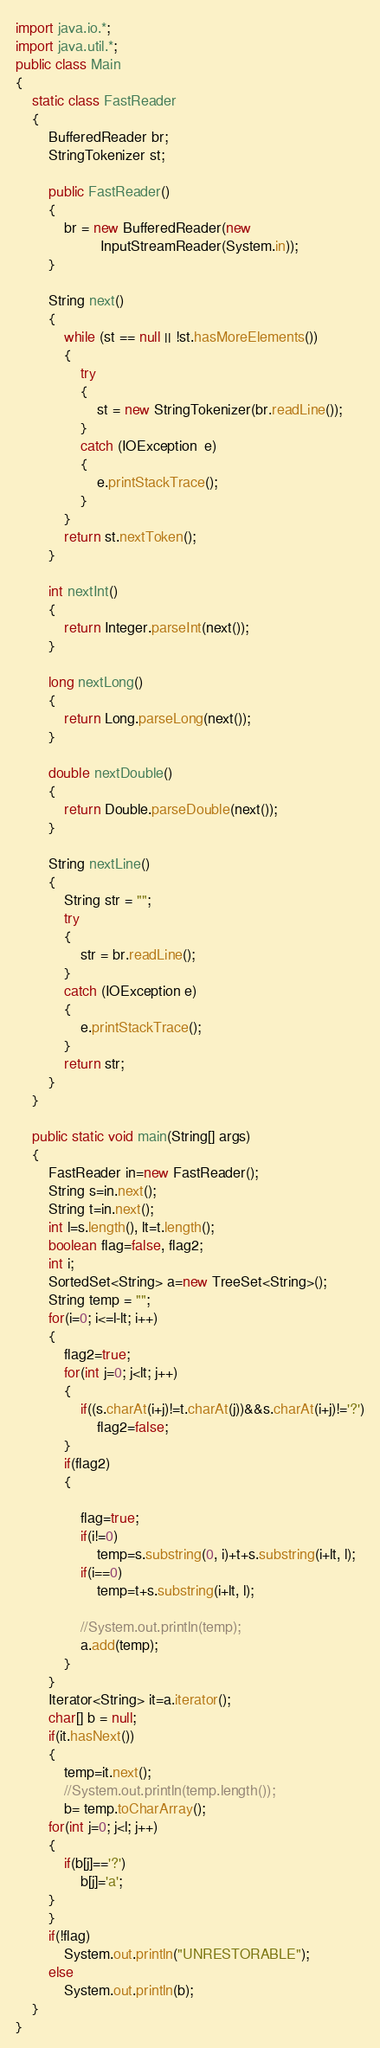Convert code to text. <code><loc_0><loc_0><loc_500><loc_500><_Java_>import java.io.*;
import java.util.*;
public class Main
{
    static class FastReader
    {
        BufferedReader br;
        StringTokenizer st;
 
        public FastReader()
        {
            br = new BufferedReader(new
                     InputStreamReader(System.in));
        }
 
        String next()
        {
            while (st == null || !st.hasMoreElements())
            {
                try
                {
                    st = new StringTokenizer(br.readLine());
                }
                catch (IOException  e)
                {
                    e.printStackTrace();
                }
            }
            return st.nextToken();
        }
 
        int nextInt()
        {
            return Integer.parseInt(next());
        }
 
        long nextLong()
        {
            return Long.parseLong(next());
        }
 
        double nextDouble()
        {
            return Double.parseDouble(next());
        }
 
        String nextLine()
        {
            String str = "";
            try
            {
                str = br.readLine();
            }
            catch (IOException e)
            {
                e.printStackTrace();
            }
            return str;
        }
    }
 
    public static void main(String[] args)
    {
        FastReader in=new FastReader();
        String s=in.next();
        String t=in.next();
        int l=s.length(), lt=t.length();
        boolean flag=false, flag2;
        int i;
        SortedSet<String> a=new TreeSet<String>();
        String temp = "";
        for(i=0; i<=l-lt; i++)
        {
        	flag2=true;
        	for(int j=0; j<lt; j++)
        	{
        		if((s.charAt(i+j)!=t.charAt(j))&&s.charAt(i+j)!='?')
        			flag2=false;
        	}
        	if(flag2)
        	{
        		
        		flag=true;
        		if(i!=0)
        			temp=s.substring(0, i)+t+s.substring(i+lt, l);
        		if(i==0)
        			temp=t+s.substring(i+lt, l);
        		
        		//System.out.println(temp);
        		a.add(temp);
        	}
        }
        Iterator<String> it=a.iterator();
        char[] b = null;
        if(it.hasNext())
        {
        	temp=it.next();
        	//System.out.println(temp.length());
        	b= temp.toCharArray();
        for(int j=0; j<l; j++)
        {
        	if(b[j]=='?')
        		b[j]='a';
        }
        }
        if(!flag)
        	System.out.println("UNRESTORABLE");
        else
        	System.out.println(b);
    }
}</code> 